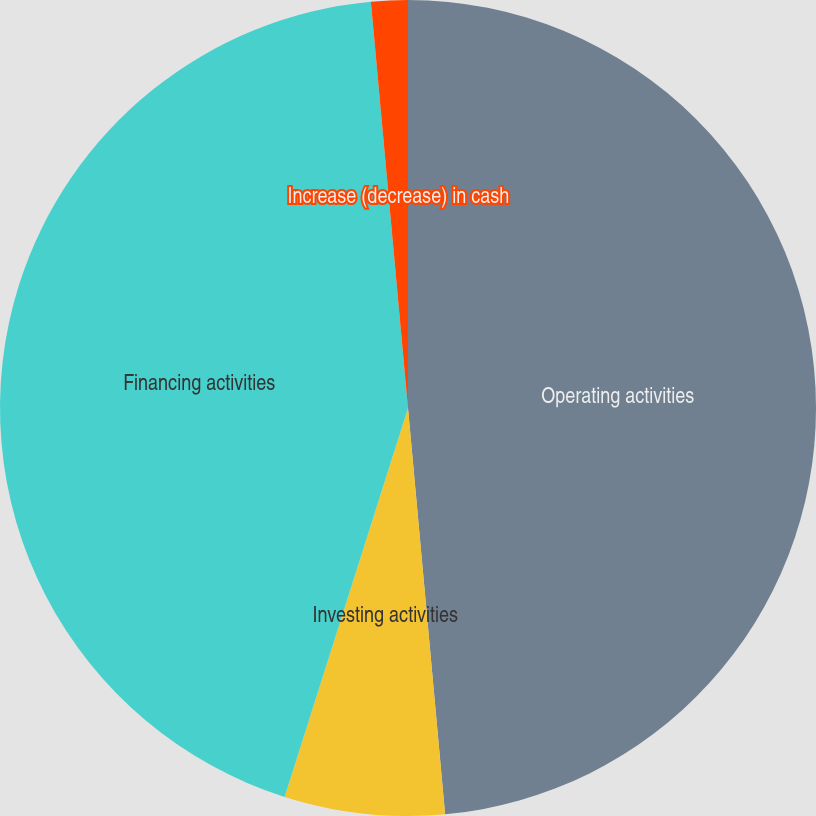<chart> <loc_0><loc_0><loc_500><loc_500><pie_chart><fcel>Operating activities<fcel>Investing activities<fcel>Financing activities<fcel>Increase (decrease) in cash<nl><fcel>48.55%<fcel>6.34%<fcel>43.66%<fcel>1.45%<nl></chart> 